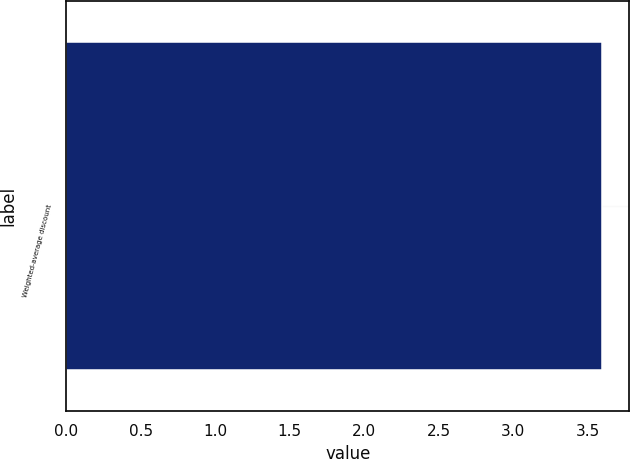<chart> <loc_0><loc_0><loc_500><loc_500><bar_chart><fcel>Weighted-average discount<nl><fcel>3.6<nl></chart> 